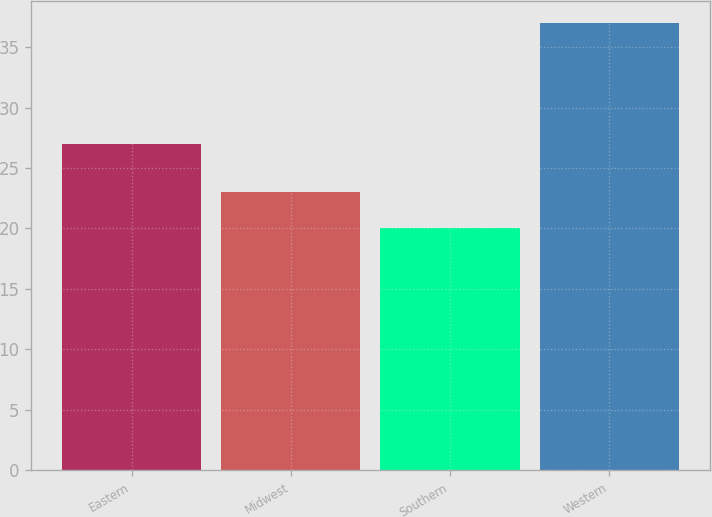Convert chart. <chart><loc_0><loc_0><loc_500><loc_500><bar_chart><fcel>Eastern<fcel>Midwest<fcel>Southern<fcel>Western<nl><fcel>27<fcel>23<fcel>20<fcel>37<nl></chart> 